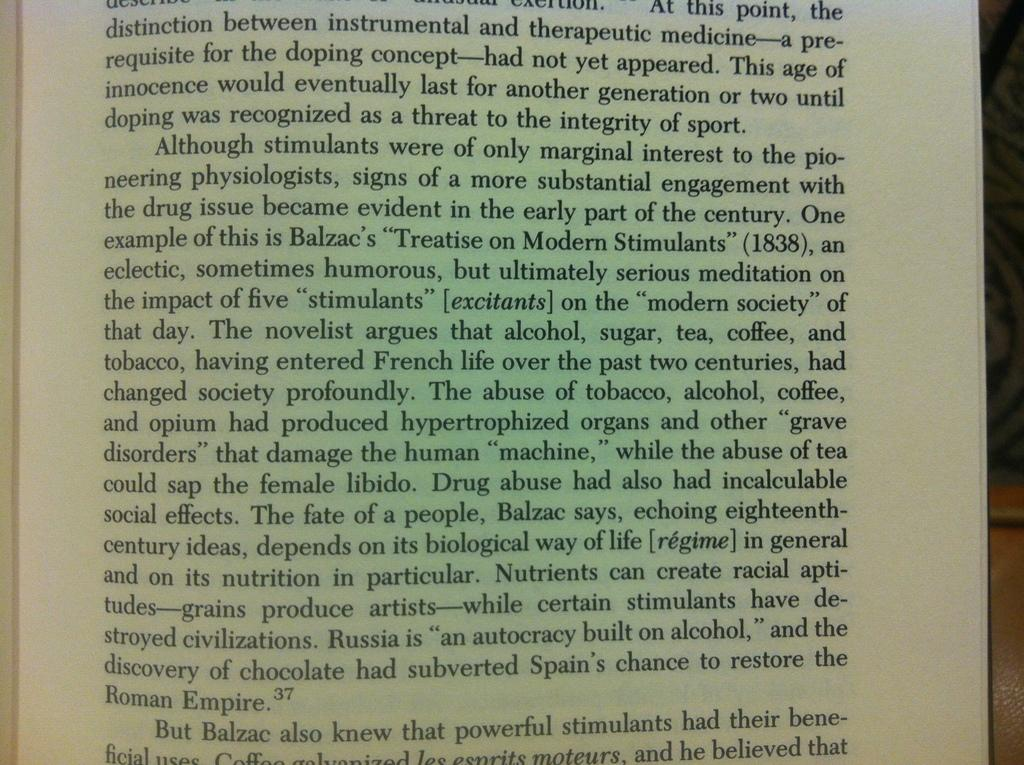<image>
Relay a brief, clear account of the picture shown. The book discusses the fact that Balzac knew that powerful stimulants had their beneficial uses. 